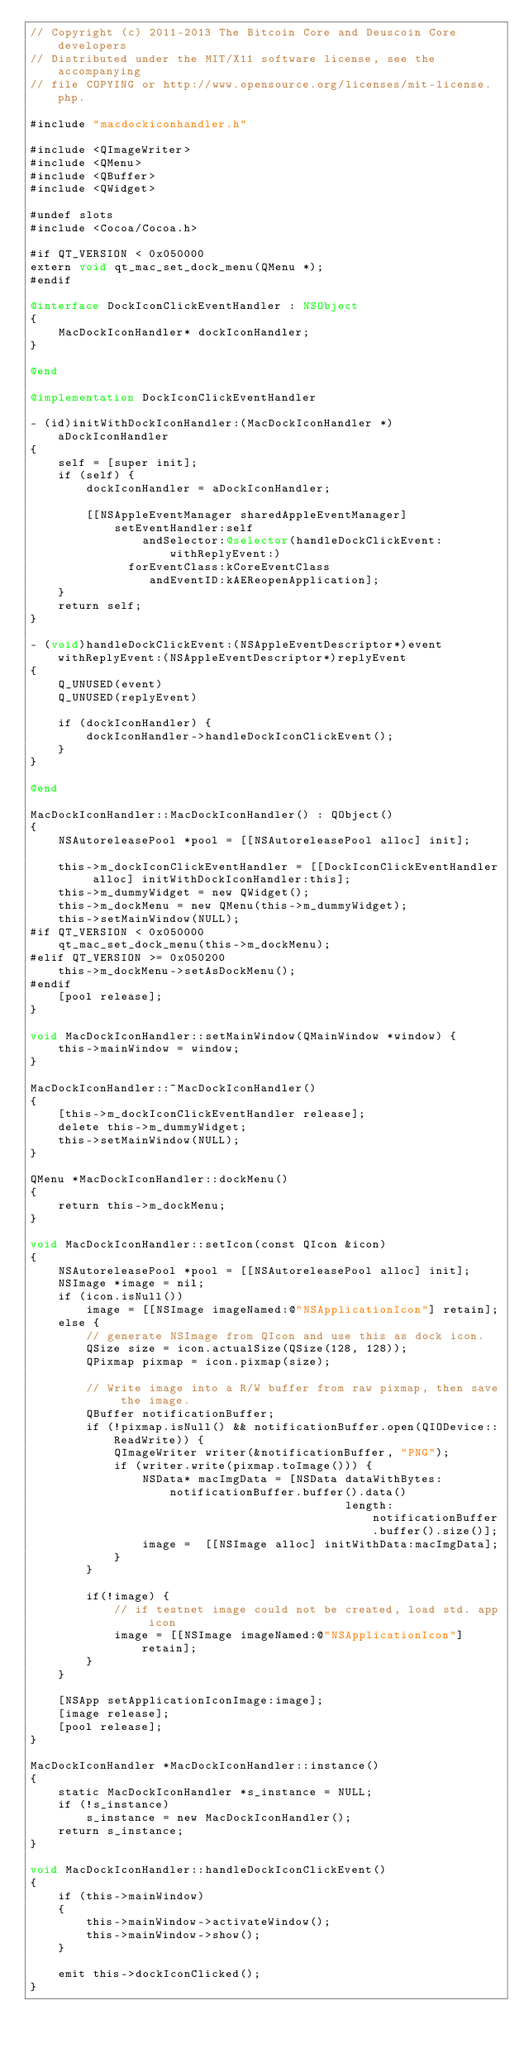Convert code to text. <code><loc_0><loc_0><loc_500><loc_500><_ObjectiveC_>// Copyright (c) 2011-2013 The Bitcoin Core and Deuscoin Core developers
// Distributed under the MIT/X11 software license, see the accompanying
// file COPYING or http://www.opensource.org/licenses/mit-license.php.

#include "macdockiconhandler.h"

#include <QImageWriter>
#include <QMenu>
#include <QBuffer>
#include <QWidget>

#undef slots
#include <Cocoa/Cocoa.h>

#if QT_VERSION < 0x050000
extern void qt_mac_set_dock_menu(QMenu *);
#endif

@interface DockIconClickEventHandler : NSObject
{
    MacDockIconHandler* dockIconHandler;
}

@end

@implementation DockIconClickEventHandler

- (id)initWithDockIconHandler:(MacDockIconHandler *)aDockIconHandler
{
    self = [super init];
    if (self) {
        dockIconHandler = aDockIconHandler;

        [[NSAppleEventManager sharedAppleEventManager]
            setEventHandler:self
                andSelector:@selector(handleDockClickEvent:withReplyEvent:)
              forEventClass:kCoreEventClass
                 andEventID:kAEReopenApplication];
    }
    return self;
}

- (void)handleDockClickEvent:(NSAppleEventDescriptor*)event withReplyEvent:(NSAppleEventDescriptor*)replyEvent
{
    Q_UNUSED(event)
    Q_UNUSED(replyEvent)

    if (dockIconHandler) {
        dockIconHandler->handleDockIconClickEvent();
    }
}

@end

MacDockIconHandler::MacDockIconHandler() : QObject()
{
    NSAutoreleasePool *pool = [[NSAutoreleasePool alloc] init];

    this->m_dockIconClickEventHandler = [[DockIconClickEventHandler alloc] initWithDockIconHandler:this];
    this->m_dummyWidget = new QWidget();
    this->m_dockMenu = new QMenu(this->m_dummyWidget);
    this->setMainWindow(NULL);
#if QT_VERSION < 0x050000
    qt_mac_set_dock_menu(this->m_dockMenu);
#elif QT_VERSION >= 0x050200
    this->m_dockMenu->setAsDockMenu();
#endif
    [pool release];
}

void MacDockIconHandler::setMainWindow(QMainWindow *window) {
    this->mainWindow = window;
}

MacDockIconHandler::~MacDockIconHandler()
{
    [this->m_dockIconClickEventHandler release];
    delete this->m_dummyWidget;
    this->setMainWindow(NULL);
}

QMenu *MacDockIconHandler::dockMenu()
{
    return this->m_dockMenu;
}

void MacDockIconHandler::setIcon(const QIcon &icon)
{
    NSAutoreleasePool *pool = [[NSAutoreleasePool alloc] init];
    NSImage *image = nil;
    if (icon.isNull())
        image = [[NSImage imageNamed:@"NSApplicationIcon"] retain];
    else {
        // generate NSImage from QIcon and use this as dock icon.
        QSize size = icon.actualSize(QSize(128, 128));
        QPixmap pixmap = icon.pixmap(size);

        // Write image into a R/W buffer from raw pixmap, then save the image.
        QBuffer notificationBuffer;
        if (!pixmap.isNull() && notificationBuffer.open(QIODevice::ReadWrite)) {
            QImageWriter writer(&notificationBuffer, "PNG");
            if (writer.write(pixmap.toImage())) {
                NSData* macImgData = [NSData dataWithBytes:notificationBuffer.buffer().data()
                                             length:notificationBuffer.buffer().size()];
                image =  [[NSImage alloc] initWithData:macImgData];
            }
        }

        if(!image) {
            // if testnet image could not be created, load std. app icon
            image = [[NSImage imageNamed:@"NSApplicationIcon"] retain];
        }
    }

    [NSApp setApplicationIconImage:image];
    [image release];
    [pool release];
}

MacDockIconHandler *MacDockIconHandler::instance()
{
    static MacDockIconHandler *s_instance = NULL;
    if (!s_instance)
        s_instance = new MacDockIconHandler();
    return s_instance;
}

void MacDockIconHandler::handleDockIconClickEvent()
{
    if (this->mainWindow)
    {
        this->mainWindow->activateWindow();
        this->mainWindow->show();
    }

    emit this->dockIconClicked();
}
</code> 